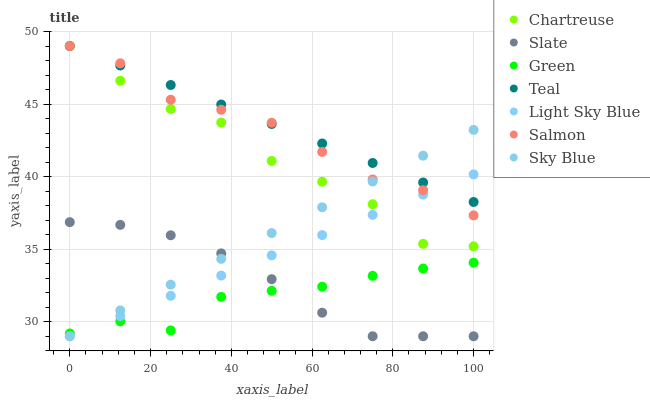Does Green have the minimum area under the curve?
Answer yes or no. Yes. Does Teal have the maximum area under the curve?
Answer yes or no. Yes. Does Salmon have the minimum area under the curve?
Answer yes or no. No. Does Salmon have the maximum area under the curve?
Answer yes or no. No. Is Light Sky Blue the smoothest?
Answer yes or no. Yes. Is Chartreuse the roughest?
Answer yes or no. Yes. Is Salmon the smoothest?
Answer yes or no. No. Is Salmon the roughest?
Answer yes or no. No. Does Slate have the lowest value?
Answer yes or no. Yes. Does Salmon have the lowest value?
Answer yes or no. No. Does Teal have the highest value?
Answer yes or no. Yes. Does Light Sky Blue have the highest value?
Answer yes or no. No. Is Green less than Salmon?
Answer yes or no. Yes. Is Chartreuse greater than Slate?
Answer yes or no. Yes. Does Slate intersect Sky Blue?
Answer yes or no. Yes. Is Slate less than Sky Blue?
Answer yes or no. No. Is Slate greater than Sky Blue?
Answer yes or no. No. Does Green intersect Salmon?
Answer yes or no. No. 